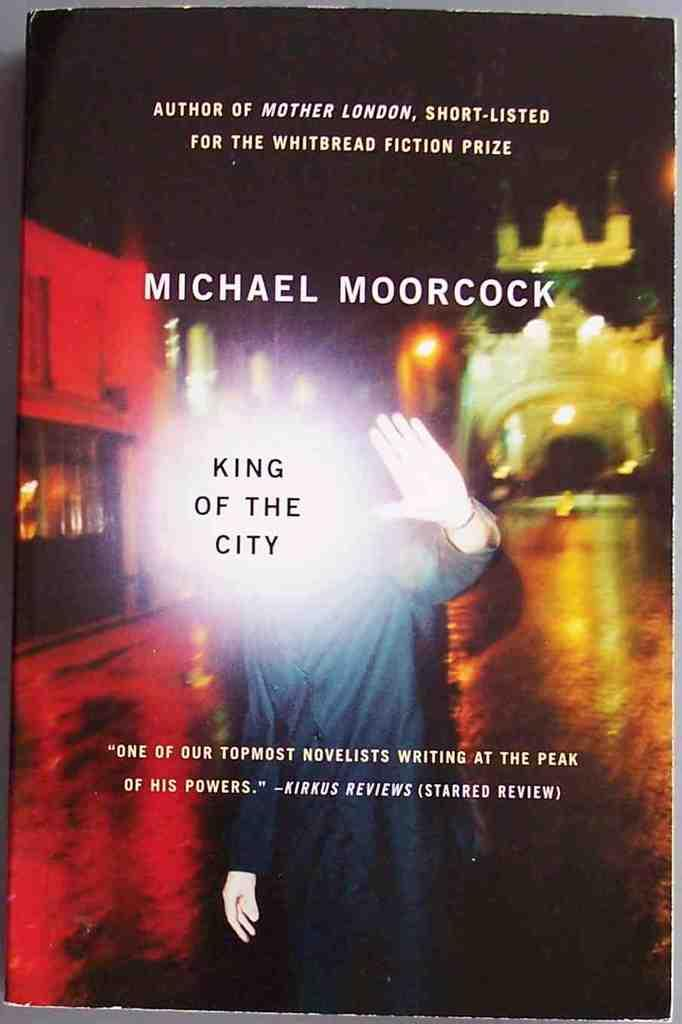<image>
Write a terse but informative summary of the picture. The King of the City standing in front of a bridge with his hand held up. 